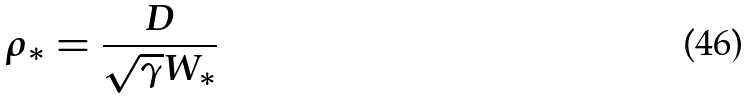Convert formula to latex. <formula><loc_0><loc_0><loc_500><loc_500>\rho _ { * } = \frac { D } { \sqrt { \gamma } W _ { * } }</formula> 